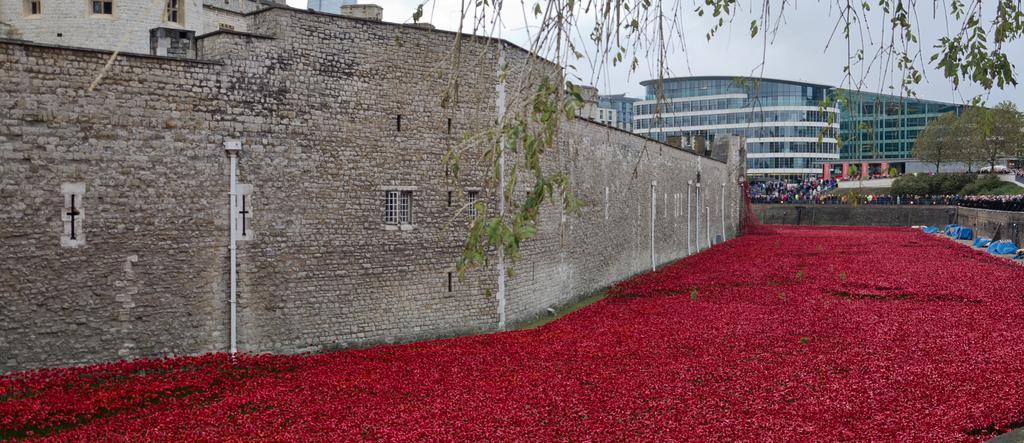In one or two sentences, can you explain what this image depicts? In this image I can see flowers in red color, background I can see few buildings in white, cream color. I can also see few persons, and trees in green color and the sky is in white color. 